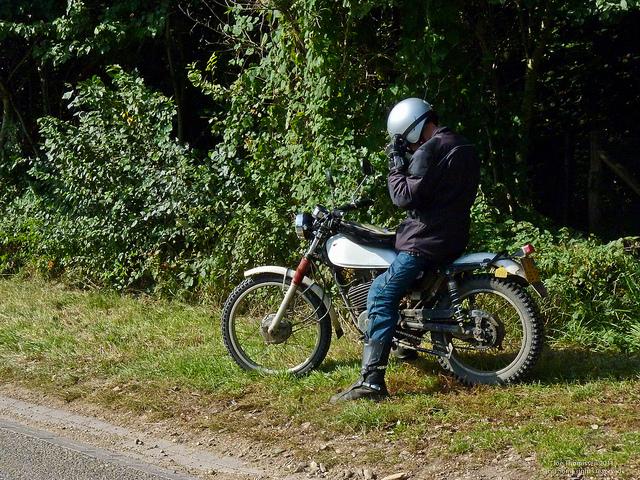Is the man smiling?
Answer briefly. No. What color are his boots?
Quick response, please. Black. What color is the helmet the person is wearing?
Quick response, please. Silver. Is this person in motion?
Be succinct. No. How many riders do you see?
Keep it brief. 1. Is this bike good on dirt roads?
Short answer required. Yes. What color is the photo?
Concise answer only. Green. 